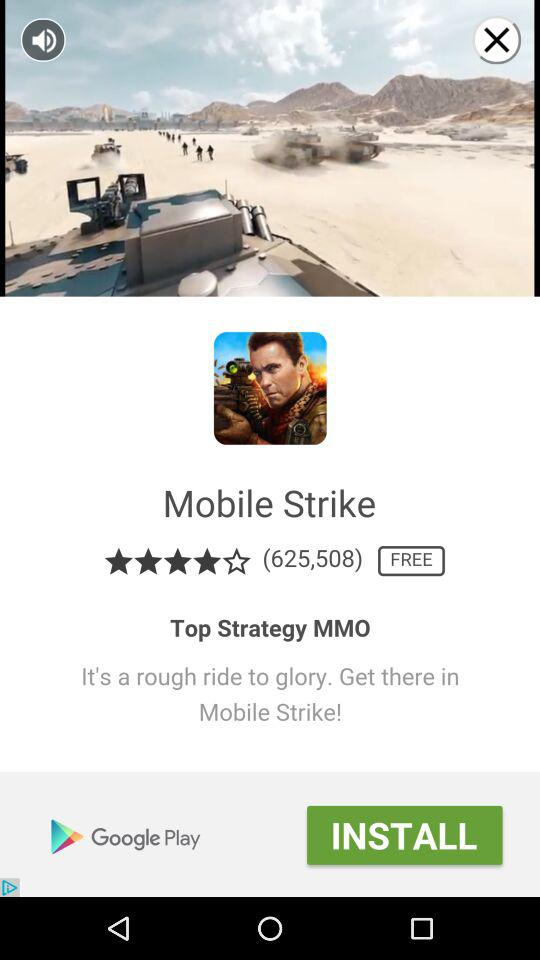How many reviews does Mobile Strike have?
Answer the question using a single word or phrase. 625,508 